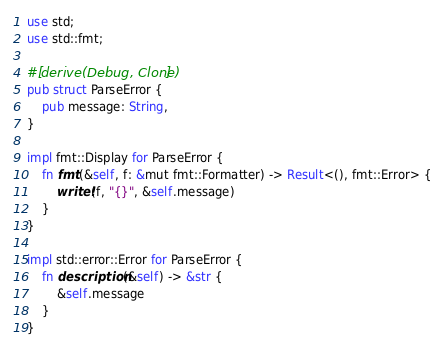<code> <loc_0><loc_0><loc_500><loc_500><_Rust_>use std;
use std::fmt;

#[derive(Debug, Clone)]
pub struct ParseError {
    pub message: String,
}

impl fmt::Display for ParseError {
    fn fmt(&self, f: &mut fmt::Formatter) -> Result<(), fmt::Error> {
        write!(f, "{}", &self.message)
    }
}

impl std::error::Error for ParseError {
    fn description(&self) -> &str {
        &self.message
    }
}
</code> 